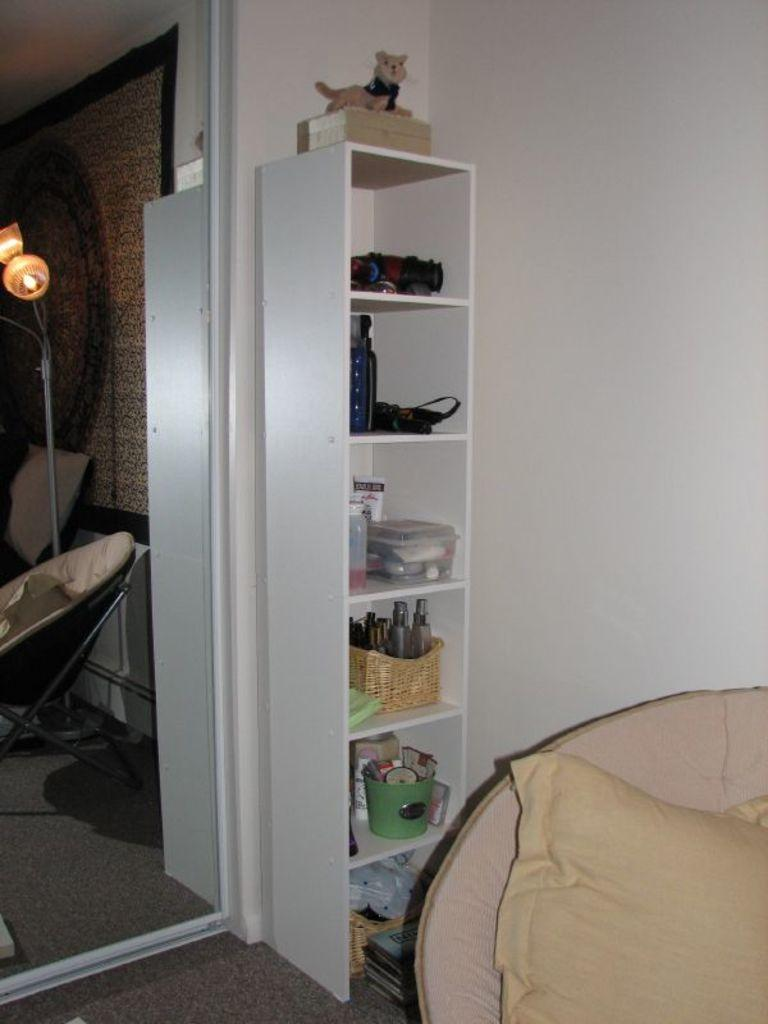What type of furniture is present in the image? There is a chair in the image. What is a source of illumination in the image? There is a light in the image. What type of soft furnishings can be seen in the image? There are pillows in the image. What type of floor covering is present in the image? There is a carpet in the image. What type of architectural feature is present in the image? There is a wall in the image. What type of storage or hanging feature is present in the image? There is a rack in the image. What type of container is present in the image? There is a box in the image. What type of liquid storage is present in the image? There are bottles in the image. What type of container for holding multiple items is present in the image? There is a basket in the image. What type of plaything is present in the image? There is a toy in the image. Who is the creator of the harmony in the image? There is no reference to harmony in the image, so it is not possible to determine who created it. 